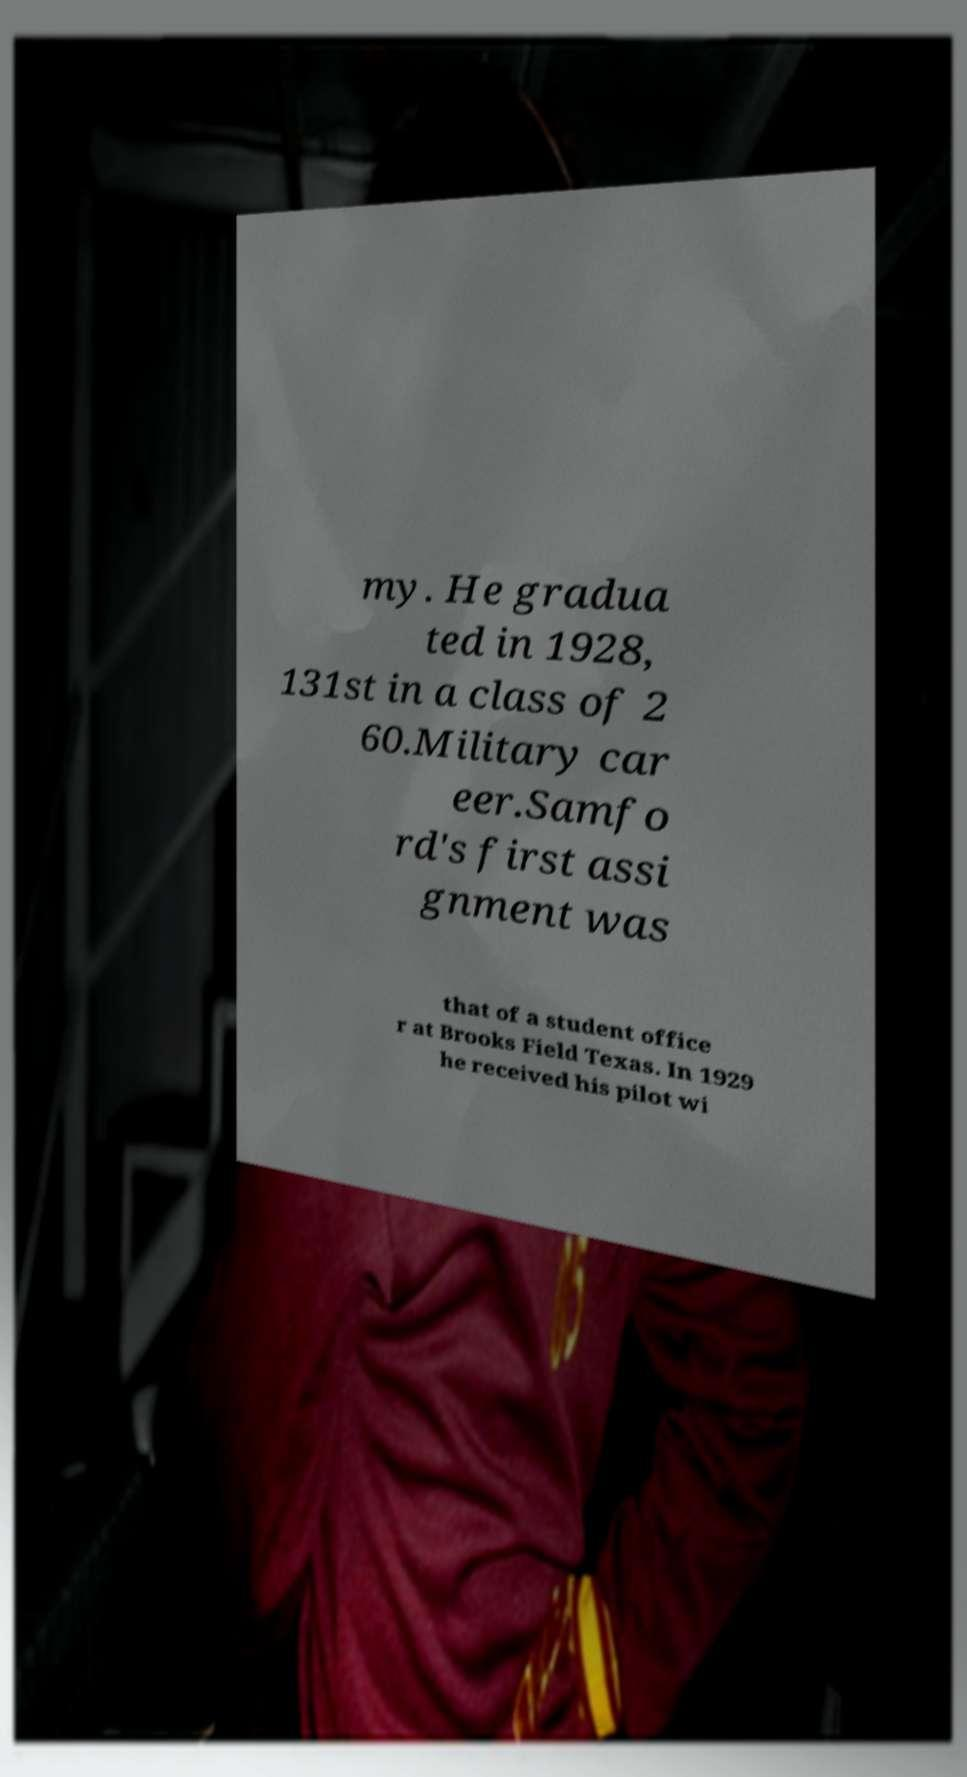Please read and relay the text visible in this image. What does it say? my. He gradua ted in 1928, 131st in a class of 2 60.Military car eer.Samfo rd's first assi gnment was that of a student office r at Brooks Field Texas. In 1929 he received his pilot wi 